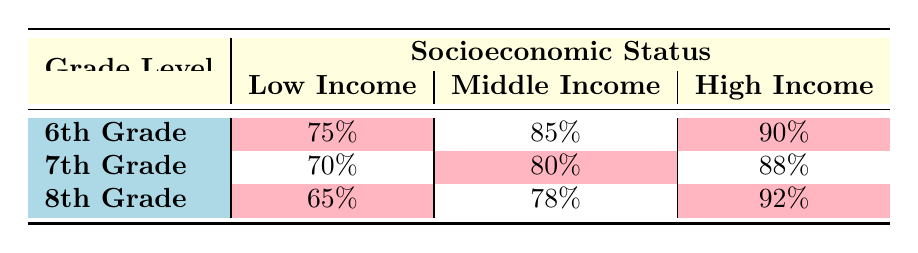What is the attendance rate for 6th Grade Low Income students? The table shows that the attendance rate for 6th Grade Low Income students is listed under that category, which is 75%.
Answer: 75% What is the highest attendance rate among Middle Income students across all grades? The attendance rates for Middle Income students are 85% (6th Grade), 80% (7th Grade), and 78% (8th Grade). The highest among these is 85%.
Answer: 85% Is the attendance rate for 8th Grade High Income students higher than that for 7th Grade High Income students? The attendance rate for 8th Grade High Income students is 92%, while for 7th Grade High Income students is 88%. Since 92 is greater than 88, it is higher.
Answer: Yes What is the attendance rate difference between 6th Grade High Income and 6th Grade Low Income students? The attendance rate for 6th Grade High Income students is 90%, and for Low Income students is 75%. The difference is calculated as 90% - 75% = 15%.
Answer: 15% What is the average attendance rate for 7th Grade students across all socioeconomic statuses? The attendance rates for 7th Grade are 70% (Low Income), 80% (Middle Income), and 88% (High Income). The average is (70 + 80 + 88) / 3 = 238 / 3 = 79.33%.
Answer: 79.33% Are 6th Grade students with Low Income attending at a higher rate than 8th Grade students with Low Income? For 6th Grade Low Income students, the attendance rate is 75%, whereas for 8th Grade Low Income students, it is 65%. Since 75 is greater than 65, they are attending at a higher rate.
Answer: Yes Which grade level has the lowest attendance rate overall? Looking at each grade level, the attendance rates are 75% (6th Grade), 70% (7th Grade), and 65% (8th Grade). The lowest among these is 65% for 8th Grade.
Answer: 8th Grade What is the combined attendance rate of 6th Grade and 7th Grade Low Income students? The attendance rates for 6th Grade Low Income students is 75% and for 7th Grade Low Income students is 70%. The combined rate can be interpreted as a simple sum: 75% + 70% = 145%. However, to get a common measure, we can average these if needed, which gives (75 + 70) / 2 = 72.5% as an average.
Answer: 145% (sum), 72.5% (average) 